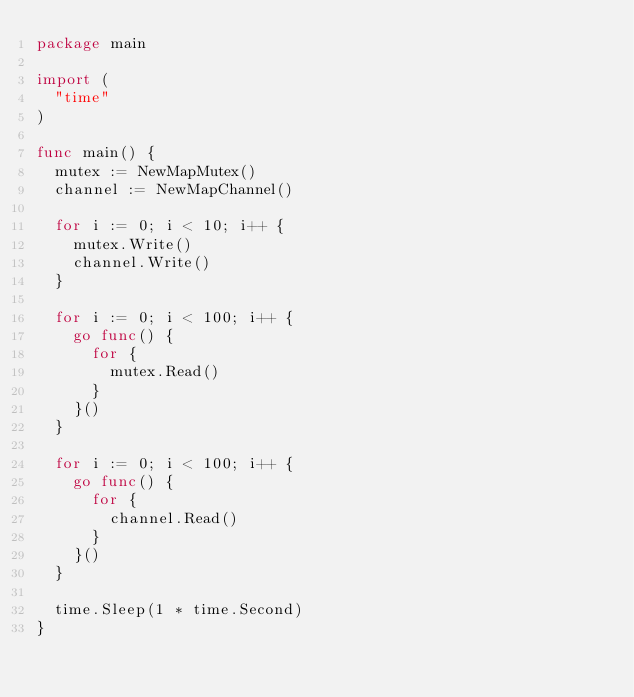Convert code to text. <code><loc_0><loc_0><loc_500><loc_500><_Go_>package main

import (
	"time"
)

func main() {
	mutex := NewMapMutex()
	channel := NewMapChannel()

	for i := 0; i < 10; i++ {
		mutex.Write()
		channel.Write()
	}

	for i := 0; i < 100; i++ {
		go func() {
			for {
				mutex.Read()
			}
		}()
	}

	for i := 0; i < 100; i++ {
		go func() {
			for {
				channel.Read()
			}
		}()
	}

	time.Sleep(1 * time.Second)
}
</code> 